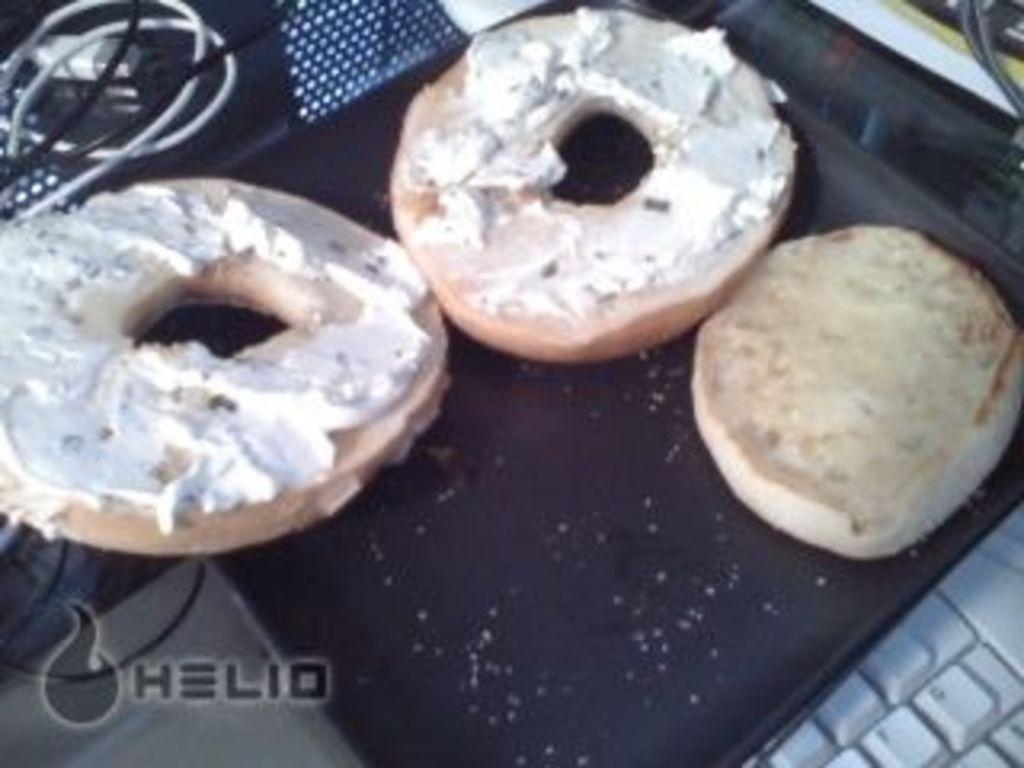What type of food is in the image? There is a doughnut in the image. What is on top of the doughnut? The doughnut has cream on it. What color is the cream on the doughnut? The cream is white in color. Where is the doughnut placed? The doughnut is on a plate. What electronic device is at the bottom of the image? There is a keyboard at the bottom of the image. What can be seen at the top of the image? There are wires visible at the top of the image. How does the doughnut react to the rainstorm in the image? There is no rainstorm present in the image, so the doughnut does not react to it. Can you tell me how many flies are on the doughnut in the image? There are no flies visible on the doughnut in the image. 